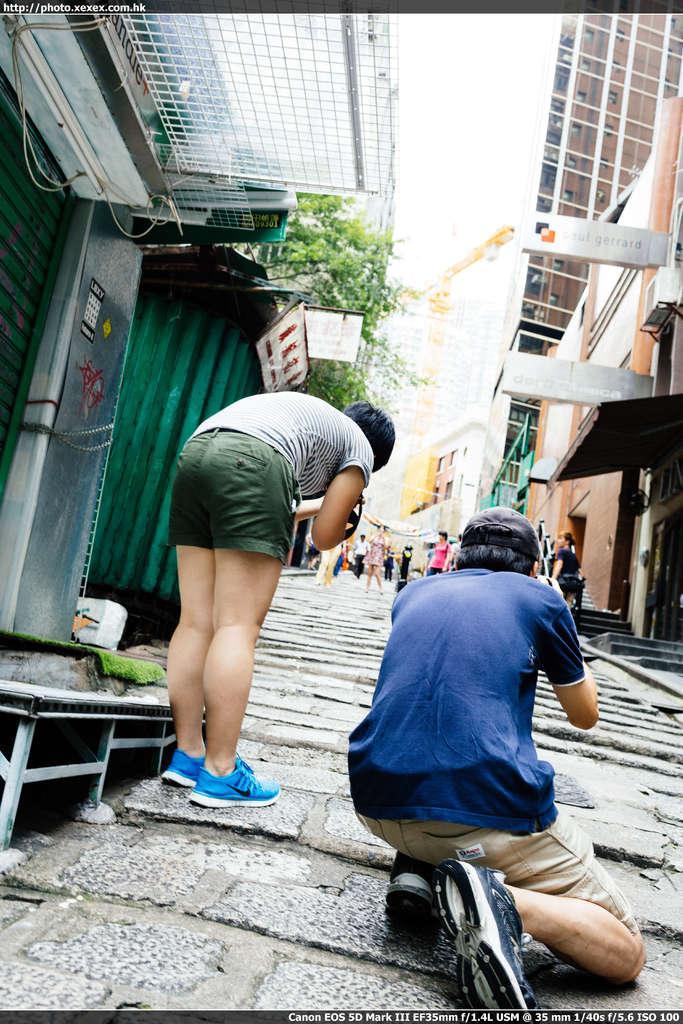Describe this image in one or two sentences. In this picture I can see two persons, there are houses, boards, trees, there are group of people, and in the background there is sky and there are watermarks on the image. 